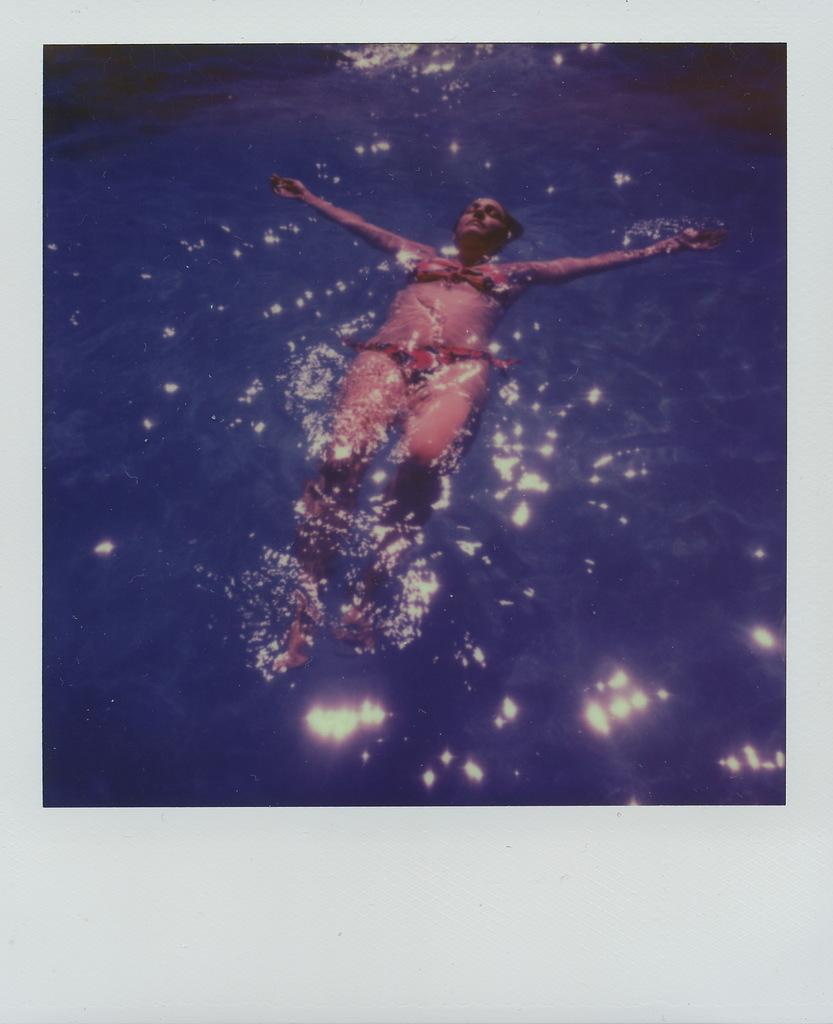What is the visual characteristic of the image? The image has borders. Who is present in the image? There is a lady in the image. What is the lady doing in the image? The lady is swimming in water. What type of scarf is the lady wearing while swimming in the image? There is no scarf visible in the image; the lady is swimming in water. What meal is being prepared in the background of the image? There is no meal preparation visible in the image; the lady is swimming in water. 